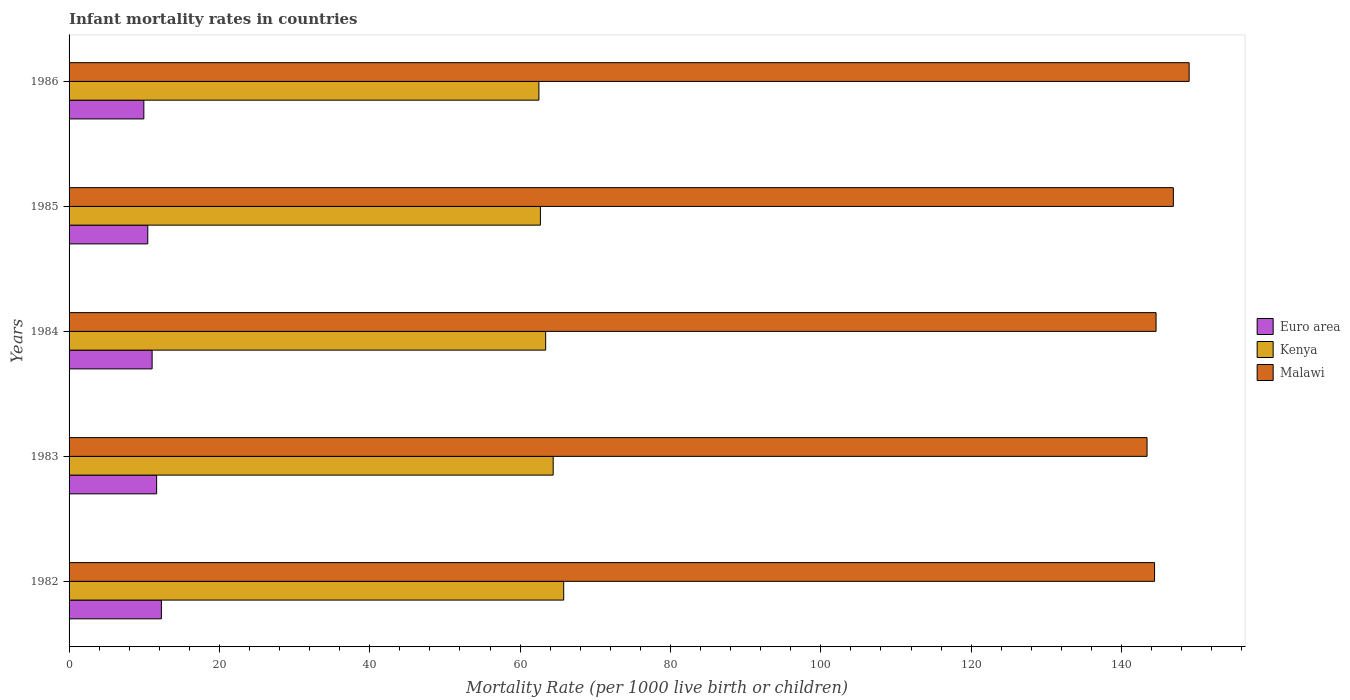How many groups of bars are there?
Ensure brevity in your answer.  5. How many bars are there on the 2nd tick from the top?
Make the answer very short. 3. In how many cases, is the number of bars for a given year not equal to the number of legend labels?
Ensure brevity in your answer.  0. What is the infant mortality rate in Euro area in 1986?
Ensure brevity in your answer.  9.95. Across all years, what is the maximum infant mortality rate in Euro area?
Offer a very short reply. 12.28. Across all years, what is the minimum infant mortality rate in Malawi?
Offer a very short reply. 143.4. In which year was the infant mortality rate in Kenya maximum?
Keep it short and to the point. 1982. In which year was the infant mortality rate in Kenya minimum?
Your response must be concise. 1986. What is the total infant mortality rate in Euro area in the graph?
Give a very brief answer. 55.4. What is the difference between the infant mortality rate in Malawi in 1983 and that in 1985?
Your answer should be compact. -3.5. What is the difference between the infant mortality rate in Malawi in 1986 and the infant mortality rate in Kenya in 1984?
Make the answer very short. 85.6. What is the average infant mortality rate in Kenya per year?
Keep it short and to the point. 63.76. In the year 1983, what is the difference between the infant mortality rate in Kenya and infant mortality rate in Euro area?
Make the answer very short. 52.75. In how many years, is the infant mortality rate in Malawi greater than 76 ?
Offer a terse response. 5. Is the infant mortality rate in Kenya in 1982 less than that in 1986?
Your answer should be very brief. No. Is the difference between the infant mortality rate in Kenya in 1984 and 1986 greater than the difference between the infant mortality rate in Euro area in 1984 and 1986?
Your answer should be very brief. No. What is the difference between the highest and the second highest infant mortality rate in Euro area?
Make the answer very short. 0.63. What is the difference between the highest and the lowest infant mortality rate in Malawi?
Your answer should be very brief. 5.6. In how many years, is the infant mortality rate in Euro area greater than the average infant mortality rate in Euro area taken over all years?
Offer a very short reply. 2. Is the sum of the infant mortality rate in Malawi in 1984 and 1986 greater than the maximum infant mortality rate in Euro area across all years?
Your answer should be compact. Yes. What does the 2nd bar from the top in 1986 represents?
Provide a short and direct response. Kenya. What does the 3rd bar from the bottom in 1985 represents?
Your response must be concise. Malawi. Is it the case that in every year, the sum of the infant mortality rate in Kenya and infant mortality rate in Malawi is greater than the infant mortality rate in Euro area?
Provide a short and direct response. Yes. Are all the bars in the graph horizontal?
Your response must be concise. Yes. Are the values on the major ticks of X-axis written in scientific E-notation?
Your answer should be compact. No. Does the graph contain grids?
Provide a succinct answer. No. Where does the legend appear in the graph?
Keep it short and to the point. Center right. How are the legend labels stacked?
Ensure brevity in your answer.  Vertical. What is the title of the graph?
Your answer should be compact. Infant mortality rates in countries. Does "New Caledonia" appear as one of the legend labels in the graph?
Provide a succinct answer. No. What is the label or title of the X-axis?
Make the answer very short. Mortality Rate (per 1000 live birth or children). What is the Mortality Rate (per 1000 live birth or children) in Euro area in 1982?
Offer a terse response. 12.28. What is the Mortality Rate (per 1000 live birth or children) in Kenya in 1982?
Make the answer very short. 65.8. What is the Mortality Rate (per 1000 live birth or children) of Malawi in 1982?
Your answer should be compact. 144.4. What is the Mortality Rate (per 1000 live birth or children) of Euro area in 1983?
Ensure brevity in your answer.  11.65. What is the Mortality Rate (per 1000 live birth or children) of Kenya in 1983?
Offer a very short reply. 64.4. What is the Mortality Rate (per 1000 live birth or children) in Malawi in 1983?
Your answer should be compact. 143.4. What is the Mortality Rate (per 1000 live birth or children) of Euro area in 1984?
Your answer should be very brief. 11.05. What is the Mortality Rate (per 1000 live birth or children) of Kenya in 1984?
Give a very brief answer. 63.4. What is the Mortality Rate (per 1000 live birth or children) of Malawi in 1984?
Provide a short and direct response. 144.6. What is the Mortality Rate (per 1000 live birth or children) in Euro area in 1985?
Your answer should be compact. 10.47. What is the Mortality Rate (per 1000 live birth or children) in Kenya in 1985?
Ensure brevity in your answer.  62.7. What is the Mortality Rate (per 1000 live birth or children) in Malawi in 1985?
Ensure brevity in your answer.  146.9. What is the Mortality Rate (per 1000 live birth or children) of Euro area in 1986?
Make the answer very short. 9.95. What is the Mortality Rate (per 1000 live birth or children) in Kenya in 1986?
Offer a very short reply. 62.5. What is the Mortality Rate (per 1000 live birth or children) in Malawi in 1986?
Your answer should be very brief. 149. Across all years, what is the maximum Mortality Rate (per 1000 live birth or children) in Euro area?
Your response must be concise. 12.28. Across all years, what is the maximum Mortality Rate (per 1000 live birth or children) of Kenya?
Offer a very short reply. 65.8. Across all years, what is the maximum Mortality Rate (per 1000 live birth or children) of Malawi?
Give a very brief answer. 149. Across all years, what is the minimum Mortality Rate (per 1000 live birth or children) of Euro area?
Your answer should be very brief. 9.95. Across all years, what is the minimum Mortality Rate (per 1000 live birth or children) in Kenya?
Your answer should be compact. 62.5. Across all years, what is the minimum Mortality Rate (per 1000 live birth or children) of Malawi?
Give a very brief answer. 143.4. What is the total Mortality Rate (per 1000 live birth or children) of Euro area in the graph?
Give a very brief answer. 55.4. What is the total Mortality Rate (per 1000 live birth or children) in Kenya in the graph?
Your answer should be compact. 318.8. What is the total Mortality Rate (per 1000 live birth or children) of Malawi in the graph?
Ensure brevity in your answer.  728.3. What is the difference between the Mortality Rate (per 1000 live birth or children) of Euro area in 1982 and that in 1983?
Your answer should be very brief. 0.63. What is the difference between the Mortality Rate (per 1000 live birth or children) of Kenya in 1982 and that in 1983?
Your answer should be very brief. 1.4. What is the difference between the Mortality Rate (per 1000 live birth or children) in Euro area in 1982 and that in 1984?
Offer a very short reply. 1.23. What is the difference between the Mortality Rate (per 1000 live birth or children) in Malawi in 1982 and that in 1984?
Give a very brief answer. -0.2. What is the difference between the Mortality Rate (per 1000 live birth or children) of Euro area in 1982 and that in 1985?
Provide a short and direct response. 1.81. What is the difference between the Mortality Rate (per 1000 live birth or children) in Kenya in 1982 and that in 1985?
Offer a terse response. 3.1. What is the difference between the Mortality Rate (per 1000 live birth or children) in Malawi in 1982 and that in 1985?
Your answer should be compact. -2.5. What is the difference between the Mortality Rate (per 1000 live birth or children) of Euro area in 1982 and that in 1986?
Give a very brief answer. 2.33. What is the difference between the Mortality Rate (per 1000 live birth or children) in Malawi in 1982 and that in 1986?
Your answer should be compact. -4.6. What is the difference between the Mortality Rate (per 1000 live birth or children) in Euro area in 1983 and that in 1984?
Your response must be concise. 0.6. What is the difference between the Mortality Rate (per 1000 live birth or children) of Kenya in 1983 and that in 1984?
Offer a very short reply. 1. What is the difference between the Mortality Rate (per 1000 live birth or children) of Euro area in 1983 and that in 1985?
Ensure brevity in your answer.  1.18. What is the difference between the Mortality Rate (per 1000 live birth or children) of Kenya in 1983 and that in 1985?
Make the answer very short. 1.7. What is the difference between the Mortality Rate (per 1000 live birth or children) in Euro area in 1983 and that in 1986?
Give a very brief answer. 1.7. What is the difference between the Mortality Rate (per 1000 live birth or children) in Euro area in 1984 and that in 1985?
Keep it short and to the point. 0.58. What is the difference between the Mortality Rate (per 1000 live birth or children) in Euro area in 1984 and that in 1986?
Keep it short and to the point. 1.1. What is the difference between the Mortality Rate (per 1000 live birth or children) in Euro area in 1985 and that in 1986?
Provide a succinct answer. 0.52. What is the difference between the Mortality Rate (per 1000 live birth or children) in Kenya in 1985 and that in 1986?
Offer a terse response. 0.2. What is the difference between the Mortality Rate (per 1000 live birth or children) of Malawi in 1985 and that in 1986?
Provide a short and direct response. -2.1. What is the difference between the Mortality Rate (per 1000 live birth or children) in Euro area in 1982 and the Mortality Rate (per 1000 live birth or children) in Kenya in 1983?
Provide a short and direct response. -52.12. What is the difference between the Mortality Rate (per 1000 live birth or children) in Euro area in 1982 and the Mortality Rate (per 1000 live birth or children) in Malawi in 1983?
Offer a very short reply. -131.12. What is the difference between the Mortality Rate (per 1000 live birth or children) of Kenya in 1982 and the Mortality Rate (per 1000 live birth or children) of Malawi in 1983?
Provide a succinct answer. -77.6. What is the difference between the Mortality Rate (per 1000 live birth or children) in Euro area in 1982 and the Mortality Rate (per 1000 live birth or children) in Kenya in 1984?
Your answer should be very brief. -51.12. What is the difference between the Mortality Rate (per 1000 live birth or children) in Euro area in 1982 and the Mortality Rate (per 1000 live birth or children) in Malawi in 1984?
Ensure brevity in your answer.  -132.32. What is the difference between the Mortality Rate (per 1000 live birth or children) of Kenya in 1982 and the Mortality Rate (per 1000 live birth or children) of Malawi in 1984?
Your response must be concise. -78.8. What is the difference between the Mortality Rate (per 1000 live birth or children) of Euro area in 1982 and the Mortality Rate (per 1000 live birth or children) of Kenya in 1985?
Provide a succinct answer. -50.42. What is the difference between the Mortality Rate (per 1000 live birth or children) of Euro area in 1982 and the Mortality Rate (per 1000 live birth or children) of Malawi in 1985?
Your answer should be compact. -134.62. What is the difference between the Mortality Rate (per 1000 live birth or children) of Kenya in 1982 and the Mortality Rate (per 1000 live birth or children) of Malawi in 1985?
Your answer should be very brief. -81.1. What is the difference between the Mortality Rate (per 1000 live birth or children) in Euro area in 1982 and the Mortality Rate (per 1000 live birth or children) in Kenya in 1986?
Your response must be concise. -50.22. What is the difference between the Mortality Rate (per 1000 live birth or children) of Euro area in 1982 and the Mortality Rate (per 1000 live birth or children) of Malawi in 1986?
Your response must be concise. -136.72. What is the difference between the Mortality Rate (per 1000 live birth or children) of Kenya in 1982 and the Mortality Rate (per 1000 live birth or children) of Malawi in 1986?
Make the answer very short. -83.2. What is the difference between the Mortality Rate (per 1000 live birth or children) in Euro area in 1983 and the Mortality Rate (per 1000 live birth or children) in Kenya in 1984?
Make the answer very short. -51.75. What is the difference between the Mortality Rate (per 1000 live birth or children) in Euro area in 1983 and the Mortality Rate (per 1000 live birth or children) in Malawi in 1984?
Keep it short and to the point. -132.95. What is the difference between the Mortality Rate (per 1000 live birth or children) of Kenya in 1983 and the Mortality Rate (per 1000 live birth or children) of Malawi in 1984?
Make the answer very short. -80.2. What is the difference between the Mortality Rate (per 1000 live birth or children) of Euro area in 1983 and the Mortality Rate (per 1000 live birth or children) of Kenya in 1985?
Provide a succinct answer. -51.05. What is the difference between the Mortality Rate (per 1000 live birth or children) in Euro area in 1983 and the Mortality Rate (per 1000 live birth or children) in Malawi in 1985?
Ensure brevity in your answer.  -135.25. What is the difference between the Mortality Rate (per 1000 live birth or children) of Kenya in 1983 and the Mortality Rate (per 1000 live birth or children) of Malawi in 1985?
Provide a short and direct response. -82.5. What is the difference between the Mortality Rate (per 1000 live birth or children) in Euro area in 1983 and the Mortality Rate (per 1000 live birth or children) in Kenya in 1986?
Your answer should be compact. -50.85. What is the difference between the Mortality Rate (per 1000 live birth or children) of Euro area in 1983 and the Mortality Rate (per 1000 live birth or children) of Malawi in 1986?
Ensure brevity in your answer.  -137.35. What is the difference between the Mortality Rate (per 1000 live birth or children) in Kenya in 1983 and the Mortality Rate (per 1000 live birth or children) in Malawi in 1986?
Your response must be concise. -84.6. What is the difference between the Mortality Rate (per 1000 live birth or children) in Euro area in 1984 and the Mortality Rate (per 1000 live birth or children) in Kenya in 1985?
Provide a succinct answer. -51.65. What is the difference between the Mortality Rate (per 1000 live birth or children) in Euro area in 1984 and the Mortality Rate (per 1000 live birth or children) in Malawi in 1985?
Provide a short and direct response. -135.85. What is the difference between the Mortality Rate (per 1000 live birth or children) in Kenya in 1984 and the Mortality Rate (per 1000 live birth or children) in Malawi in 1985?
Provide a succinct answer. -83.5. What is the difference between the Mortality Rate (per 1000 live birth or children) of Euro area in 1984 and the Mortality Rate (per 1000 live birth or children) of Kenya in 1986?
Provide a succinct answer. -51.45. What is the difference between the Mortality Rate (per 1000 live birth or children) in Euro area in 1984 and the Mortality Rate (per 1000 live birth or children) in Malawi in 1986?
Your answer should be compact. -137.95. What is the difference between the Mortality Rate (per 1000 live birth or children) of Kenya in 1984 and the Mortality Rate (per 1000 live birth or children) of Malawi in 1986?
Your response must be concise. -85.6. What is the difference between the Mortality Rate (per 1000 live birth or children) of Euro area in 1985 and the Mortality Rate (per 1000 live birth or children) of Kenya in 1986?
Provide a short and direct response. -52.03. What is the difference between the Mortality Rate (per 1000 live birth or children) of Euro area in 1985 and the Mortality Rate (per 1000 live birth or children) of Malawi in 1986?
Offer a terse response. -138.53. What is the difference between the Mortality Rate (per 1000 live birth or children) of Kenya in 1985 and the Mortality Rate (per 1000 live birth or children) of Malawi in 1986?
Keep it short and to the point. -86.3. What is the average Mortality Rate (per 1000 live birth or children) in Euro area per year?
Keep it short and to the point. 11.08. What is the average Mortality Rate (per 1000 live birth or children) in Kenya per year?
Your response must be concise. 63.76. What is the average Mortality Rate (per 1000 live birth or children) in Malawi per year?
Give a very brief answer. 145.66. In the year 1982, what is the difference between the Mortality Rate (per 1000 live birth or children) in Euro area and Mortality Rate (per 1000 live birth or children) in Kenya?
Your answer should be very brief. -53.52. In the year 1982, what is the difference between the Mortality Rate (per 1000 live birth or children) of Euro area and Mortality Rate (per 1000 live birth or children) of Malawi?
Provide a succinct answer. -132.12. In the year 1982, what is the difference between the Mortality Rate (per 1000 live birth or children) in Kenya and Mortality Rate (per 1000 live birth or children) in Malawi?
Provide a short and direct response. -78.6. In the year 1983, what is the difference between the Mortality Rate (per 1000 live birth or children) of Euro area and Mortality Rate (per 1000 live birth or children) of Kenya?
Offer a very short reply. -52.75. In the year 1983, what is the difference between the Mortality Rate (per 1000 live birth or children) in Euro area and Mortality Rate (per 1000 live birth or children) in Malawi?
Keep it short and to the point. -131.75. In the year 1983, what is the difference between the Mortality Rate (per 1000 live birth or children) in Kenya and Mortality Rate (per 1000 live birth or children) in Malawi?
Keep it short and to the point. -79. In the year 1984, what is the difference between the Mortality Rate (per 1000 live birth or children) of Euro area and Mortality Rate (per 1000 live birth or children) of Kenya?
Your answer should be compact. -52.35. In the year 1984, what is the difference between the Mortality Rate (per 1000 live birth or children) in Euro area and Mortality Rate (per 1000 live birth or children) in Malawi?
Give a very brief answer. -133.55. In the year 1984, what is the difference between the Mortality Rate (per 1000 live birth or children) of Kenya and Mortality Rate (per 1000 live birth or children) of Malawi?
Ensure brevity in your answer.  -81.2. In the year 1985, what is the difference between the Mortality Rate (per 1000 live birth or children) of Euro area and Mortality Rate (per 1000 live birth or children) of Kenya?
Provide a short and direct response. -52.23. In the year 1985, what is the difference between the Mortality Rate (per 1000 live birth or children) in Euro area and Mortality Rate (per 1000 live birth or children) in Malawi?
Provide a short and direct response. -136.43. In the year 1985, what is the difference between the Mortality Rate (per 1000 live birth or children) in Kenya and Mortality Rate (per 1000 live birth or children) in Malawi?
Offer a terse response. -84.2. In the year 1986, what is the difference between the Mortality Rate (per 1000 live birth or children) of Euro area and Mortality Rate (per 1000 live birth or children) of Kenya?
Offer a very short reply. -52.55. In the year 1986, what is the difference between the Mortality Rate (per 1000 live birth or children) in Euro area and Mortality Rate (per 1000 live birth or children) in Malawi?
Your answer should be very brief. -139.05. In the year 1986, what is the difference between the Mortality Rate (per 1000 live birth or children) of Kenya and Mortality Rate (per 1000 live birth or children) of Malawi?
Your response must be concise. -86.5. What is the ratio of the Mortality Rate (per 1000 live birth or children) in Euro area in 1982 to that in 1983?
Give a very brief answer. 1.05. What is the ratio of the Mortality Rate (per 1000 live birth or children) in Kenya in 1982 to that in 1983?
Provide a succinct answer. 1.02. What is the ratio of the Mortality Rate (per 1000 live birth or children) of Euro area in 1982 to that in 1984?
Provide a short and direct response. 1.11. What is the ratio of the Mortality Rate (per 1000 live birth or children) in Kenya in 1982 to that in 1984?
Keep it short and to the point. 1.04. What is the ratio of the Mortality Rate (per 1000 live birth or children) in Malawi in 1982 to that in 1984?
Ensure brevity in your answer.  1. What is the ratio of the Mortality Rate (per 1000 live birth or children) of Euro area in 1982 to that in 1985?
Your answer should be compact. 1.17. What is the ratio of the Mortality Rate (per 1000 live birth or children) of Kenya in 1982 to that in 1985?
Keep it short and to the point. 1.05. What is the ratio of the Mortality Rate (per 1000 live birth or children) of Malawi in 1982 to that in 1985?
Make the answer very short. 0.98. What is the ratio of the Mortality Rate (per 1000 live birth or children) of Euro area in 1982 to that in 1986?
Offer a terse response. 1.23. What is the ratio of the Mortality Rate (per 1000 live birth or children) of Kenya in 1982 to that in 1986?
Your answer should be very brief. 1.05. What is the ratio of the Mortality Rate (per 1000 live birth or children) in Malawi in 1982 to that in 1986?
Your answer should be compact. 0.97. What is the ratio of the Mortality Rate (per 1000 live birth or children) in Euro area in 1983 to that in 1984?
Make the answer very short. 1.05. What is the ratio of the Mortality Rate (per 1000 live birth or children) of Kenya in 1983 to that in 1984?
Your response must be concise. 1.02. What is the ratio of the Mortality Rate (per 1000 live birth or children) in Malawi in 1983 to that in 1984?
Offer a terse response. 0.99. What is the ratio of the Mortality Rate (per 1000 live birth or children) of Euro area in 1983 to that in 1985?
Give a very brief answer. 1.11. What is the ratio of the Mortality Rate (per 1000 live birth or children) in Kenya in 1983 to that in 1985?
Give a very brief answer. 1.03. What is the ratio of the Mortality Rate (per 1000 live birth or children) in Malawi in 1983 to that in 1985?
Your answer should be compact. 0.98. What is the ratio of the Mortality Rate (per 1000 live birth or children) of Euro area in 1983 to that in 1986?
Keep it short and to the point. 1.17. What is the ratio of the Mortality Rate (per 1000 live birth or children) in Kenya in 1983 to that in 1986?
Your answer should be compact. 1.03. What is the ratio of the Mortality Rate (per 1000 live birth or children) of Malawi in 1983 to that in 1986?
Your answer should be compact. 0.96. What is the ratio of the Mortality Rate (per 1000 live birth or children) of Euro area in 1984 to that in 1985?
Give a very brief answer. 1.06. What is the ratio of the Mortality Rate (per 1000 live birth or children) of Kenya in 1984 to that in 1985?
Your answer should be compact. 1.01. What is the ratio of the Mortality Rate (per 1000 live birth or children) in Malawi in 1984 to that in 1985?
Your answer should be very brief. 0.98. What is the ratio of the Mortality Rate (per 1000 live birth or children) of Euro area in 1984 to that in 1986?
Your answer should be very brief. 1.11. What is the ratio of the Mortality Rate (per 1000 live birth or children) in Kenya in 1984 to that in 1986?
Your answer should be compact. 1.01. What is the ratio of the Mortality Rate (per 1000 live birth or children) in Malawi in 1984 to that in 1986?
Keep it short and to the point. 0.97. What is the ratio of the Mortality Rate (per 1000 live birth or children) in Euro area in 1985 to that in 1986?
Ensure brevity in your answer.  1.05. What is the ratio of the Mortality Rate (per 1000 live birth or children) of Kenya in 1985 to that in 1986?
Provide a short and direct response. 1. What is the ratio of the Mortality Rate (per 1000 live birth or children) in Malawi in 1985 to that in 1986?
Ensure brevity in your answer.  0.99. What is the difference between the highest and the second highest Mortality Rate (per 1000 live birth or children) in Euro area?
Make the answer very short. 0.63. What is the difference between the highest and the second highest Mortality Rate (per 1000 live birth or children) in Malawi?
Your answer should be compact. 2.1. What is the difference between the highest and the lowest Mortality Rate (per 1000 live birth or children) in Euro area?
Provide a succinct answer. 2.33. 